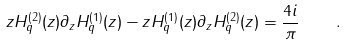<formula> <loc_0><loc_0><loc_500><loc_500>z H ^ { ( 2 ) } _ { q } ( z ) \partial _ { z } H ^ { ( 1 ) } _ { q } ( z ) - z H ^ { ( 1 ) } _ { q } ( z ) \partial _ { z } H ^ { ( 2 ) } _ { q } ( z ) = \frac { 4 i } { \pi } \quad .</formula> 